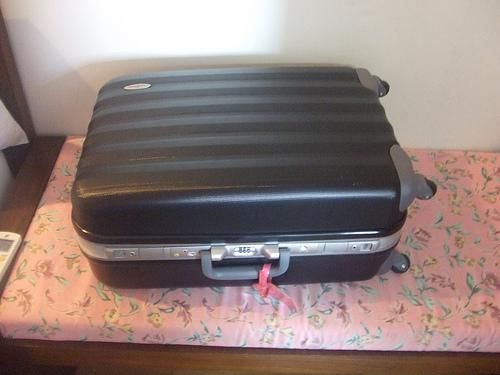Question: what is on table?
Choices:
A. Luggage.
B. Plates.
C. Bowls.
D. Silverware.
Answer with the letter. Answer: A Question: why is there a tag?
Choices:
A. To show the price.
B. To show the location.
C. Identification.
D. To mark the purpose.
Answer with the letter. Answer: C Question: where is the floral material?
Choices:
A. Under the luggage.
B. On the bed.
C. On the table.
D. Under the plates.
Answer with the letter. Answer: A 